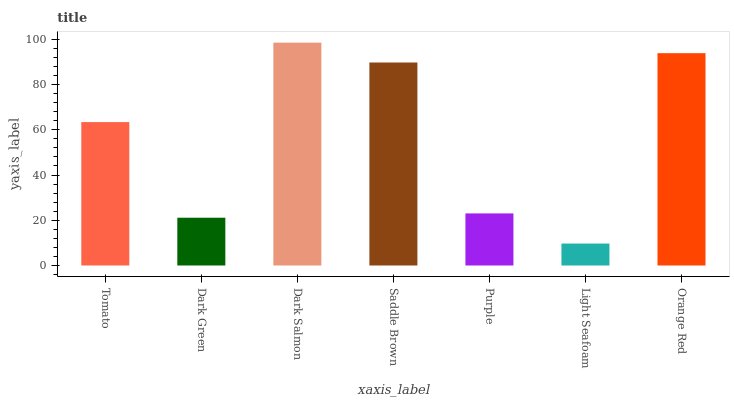Is Light Seafoam the minimum?
Answer yes or no. Yes. Is Dark Salmon the maximum?
Answer yes or no. Yes. Is Dark Green the minimum?
Answer yes or no. No. Is Dark Green the maximum?
Answer yes or no. No. Is Tomato greater than Dark Green?
Answer yes or no. Yes. Is Dark Green less than Tomato?
Answer yes or no. Yes. Is Dark Green greater than Tomato?
Answer yes or no. No. Is Tomato less than Dark Green?
Answer yes or no. No. Is Tomato the high median?
Answer yes or no. Yes. Is Tomato the low median?
Answer yes or no. Yes. Is Dark Salmon the high median?
Answer yes or no. No. Is Saddle Brown the low median?
Answer yes or no. No. 